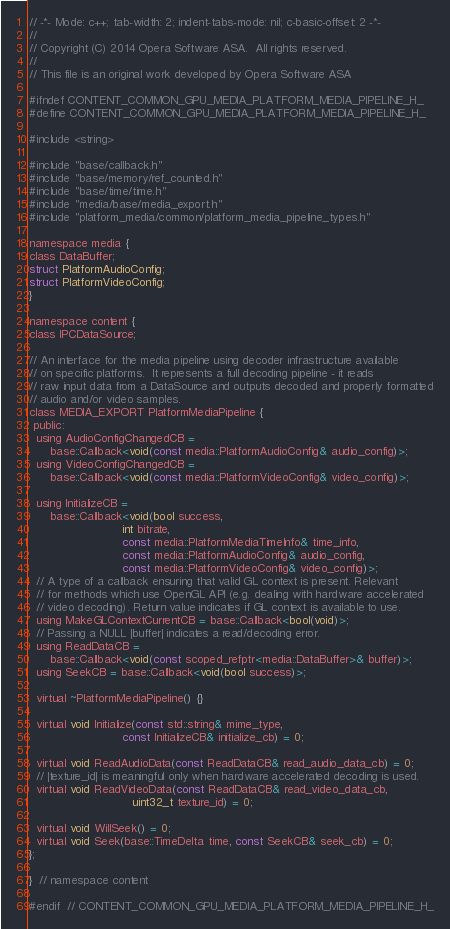<code> <loc_0><loc_0><loc_500><loc_500><_C_>// -*- Mode: c++; tab-width: 2; indent-tabs-mode: nil; c-basic-offset: 2 -*-
//
// Copyright (C) 2014 Opera Software ASA.  All rights reserved.
//
// This file is an original work developed by Opera Software ASA

#ifndef CONTENT_COMMON_GPU_MEDIA_PLATFORM_MEDIA_PIPELINE_H_
#define CONTENT_COMMON_GPU_MEDIA_PLATFORM_MEDIA_PIPELINE_H_

#include <string>

#include "base/callback.h"
#include "base/memory/ref_counted.h"
#include "base/time/time.h"
#include "media/base/media_export.h"
#include "platform_media/common/platform_media_pipeline_types.h"

namespace media {
class DataBuffer;
struct PlatformAudioConfig;
struct PlatformVideoConfig;
}

namespace content {
class IPCDataSource;

// An interface for the media pipeline using decoder infrastructure available
// on specific platforms.  It represents a full decoding pipeline - it reads
// raw input data from a DataSource and outputs decoded and properly formatted
// audio and/or video samples.
class MEDIA_EXPORT PlatformMediaPipeline {
 public:
  using AudioConfigChangedCB =
      base::Callback<void(const media::PlatformAudioConfig& audio_config)>;
  using VideoConfigChangedCB =
      base::Callback<void(const media::PlatformVideoConfig& video_config)>;

  using InitializeCB =
      base::Callback<void(bool success,
                          int bitrate,
                          const media::PlatformMediaTimeInfo& time_info,
                          const media::PlatformAudioConfig& audio_config,
                          const media::PlatformVideoConfig& video_config)>;
  // A type of a callback ensuring that valid GL context is present. Relevant
  // for methods which use OpenGL API (e.g. dealing with hardware accelerated
  // video decoding). Return value indicates if GL context is available to use.
  using MakeGLContextCurrentCB = base::Callback<bool(void)>;
  // Passing a NULL |buffer| indicates a read/decoding error.
  using ReadDataCB =
      base::Callback<void(const scoped_refptr<media::DataBuffer>& buffer)>;
  using SeekCB = base::Callback<void(bool success)>;

  virtual ~PlatformMediaPipeline() {}

  virtual void Initialize(const std::string& mime_type,
                          const InitializeCB& initialize_cb) = 0;

  virtual void ReadAudioData(const ReadDataCB& read_audio_data_cb) = 0;
  // |texture_id| is meaningful only when hardware accelerated decoding is used.
  virtual void ReadVideoData(const ReadDataCB& read_video_data_cb,
                             uint32_t texture_id) = 0;

  virtual void WillSeek() = 0;
  virtual void Seek(base::TimeDelta time, const SeekCB& seek_cb) = 0;
};

}  // namespace content

#endif  // CONTENT_COMMON_GPU_MEDIA_PLATFORM_MEDIA_PIPELINE_H_
</code> 